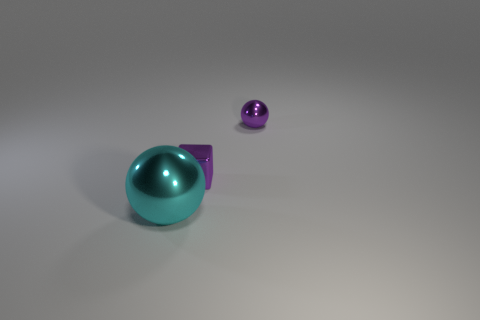Is there a small thing of the same color as the tiny sphere?
Offer a very short reply. Yes. Does the small metal thing in front of the tiny purple shiny sphere have the same color as the tiny metal ball?
Offer a very short reply. Yes. What shape is the small metallic object that is the same color as the small ball?
Offer a very short reply. Cube. Is the color of the cube the same as the tiny sphere?
Offer a terse response. Yes. There is a metal sphere that is behind the metal ball that is in front of the purple sphere; is there a object that is in front of it?
Your response must be concise. Yes. How many things are large brown metallic objects or big objects?
Make the answer very short. 1. Is there anything else of the same color as the small cube?
Your answer should be very brief. Yes. What number of things are small shiny objects that are behind the purple metal block or spheres behind the big cyan thing?
Provide a short and direct response. 1. There is a shiny object that is both left of the small purple ball and right of the cyan metal ball; what is its shape?
Keep it short and to the point. Cube. There is a sphere in front of the small metal ball; what number of purple spheres are behind it?
Your answer should be compact. 1. 